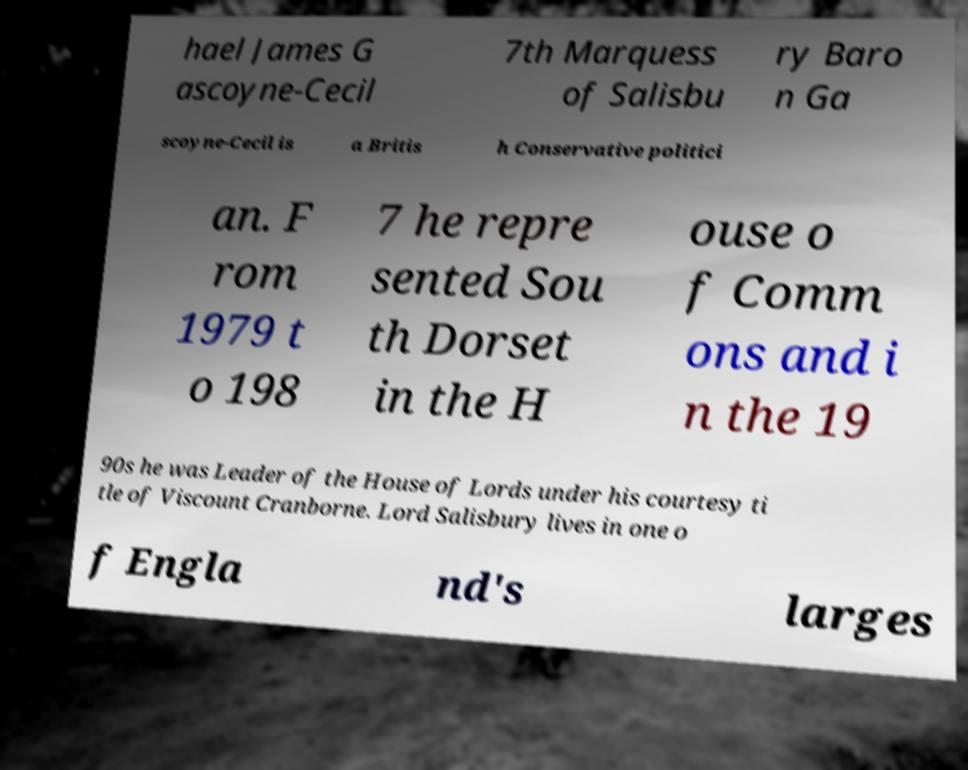Please read and relay the text visible in this image. What does it say? hael James G ascoyne-Cecil 7th Marquess of Salisbu ry Baro n Ga scoyne-Cecil is a Britis h Conservative politici an. F rom 1979 t o 198 7 he repre sented Sou th Dorset in the H ouse o f Comm ons and i n the 19 90s he was Leader of the House of Lords under his courtesy ti tle of Viscount Cranborne. Lord Salisbury lives in one o f Engla nd's larges 